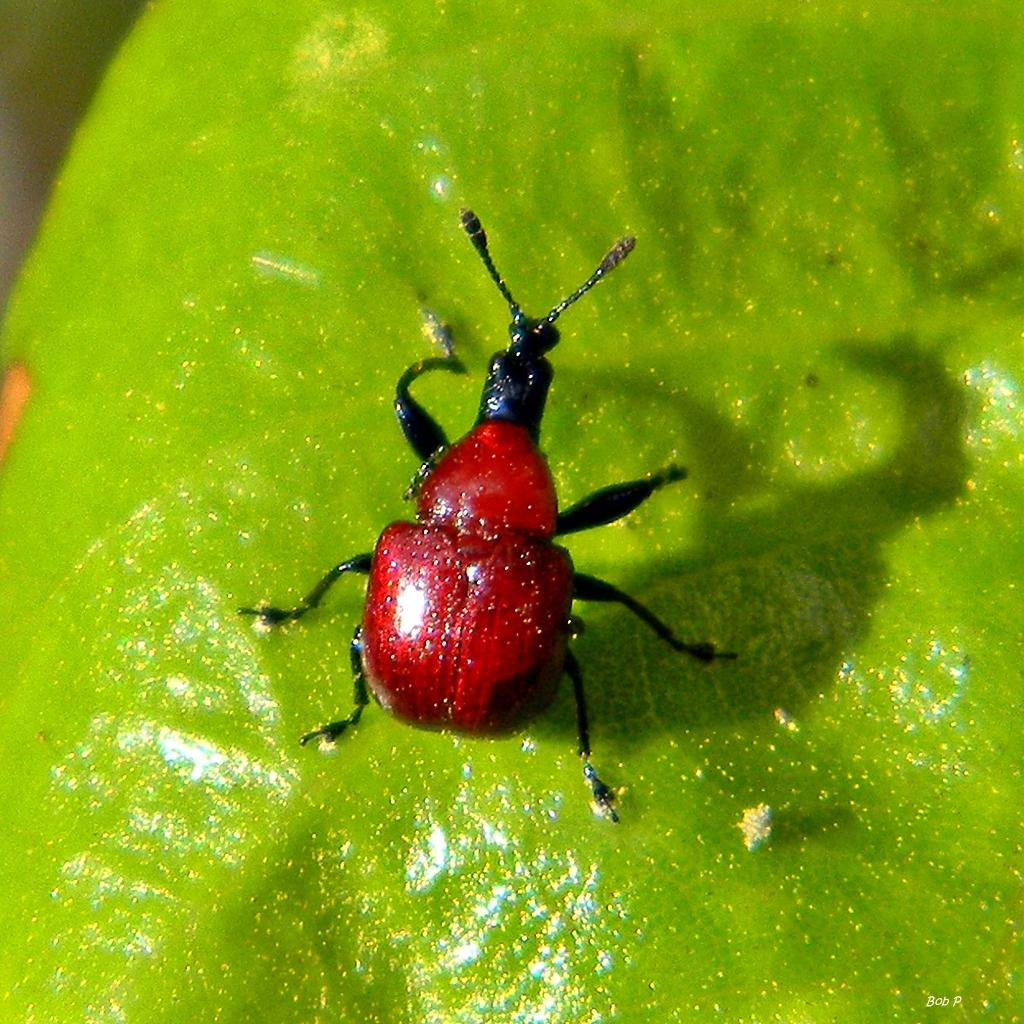What is present on the leaf in the image? There is an insect on the leaf in the image. Can you describe the insect's location on the leaf? The insect is on the leaf in the image. What type of joke is the insect telling in the image? There is no indication in the image that the insect is telling a joke, as insects do not have the ability to communicate through humor. 